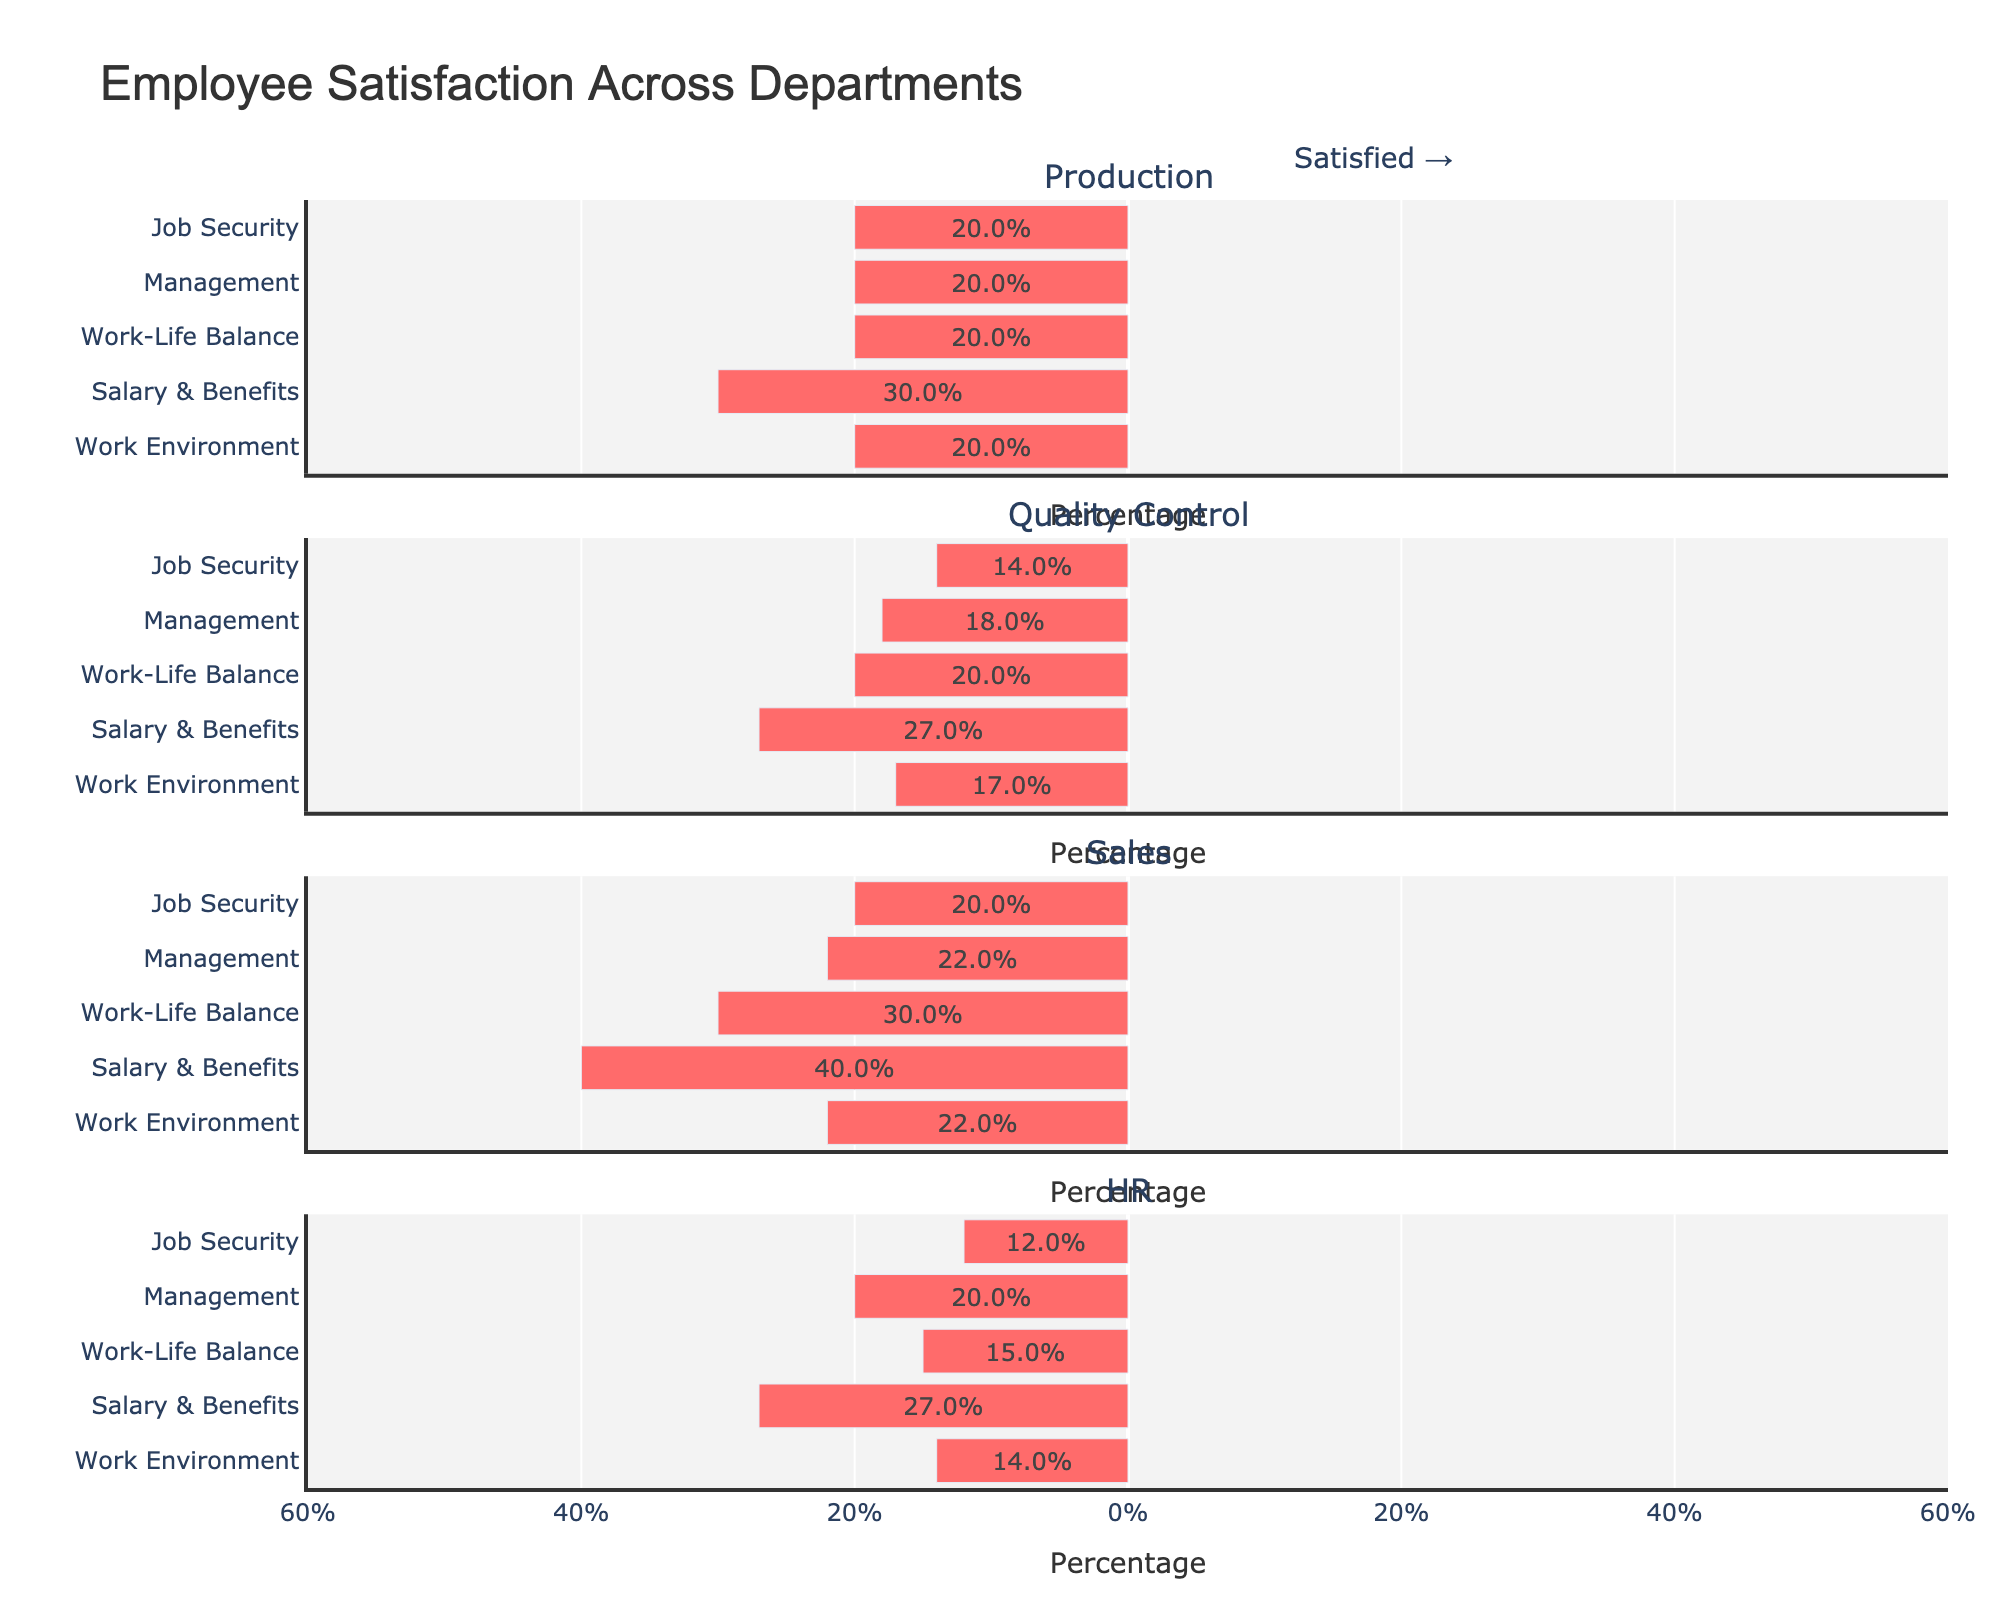What is the overall satisfaction percentage for the Production department’s Work Environment? The overall satisfaction percentage can be calculated by summing the percentages of "Satisfied" and "Very Satisfied" categories. According to the data, these are 40% and 10%, respectively.
Answer: 50% Which department has the highest percentage of employees who are very satisfied with their Job Security? Compare the "Very Satisfied" category percentages for Job Security across all departments. Production has 15%, Quality Control has 19%, Sales has 20%, and HR has 15%.
Answer: Sales Among all departments, which has the lowest percentage of employees dissatisfied with Salary & Benefits? Check the "Dissatisfied" category percentages for Salary & Benefits across all departments. Production has 20%, Quality Control has 18%, Sales has 25%, and HR has 19%.
Answer: Quality Control What is the percentage difference between very dissatisfied and very satisfied Production employees regarding Work Environment? For Production, "Very Dissatisfied" for Work Environment is 5%, and "Very Satisfied" is 10%. The percentage difference is calculated by subtracting 5% from 10%.
Answer: 5% Considering the Sales department, how does the percentage of employees who are neutral about Work-Life Balance compare to those who are satisfied? For Sales, the percentage of employees who are neutral in Work-Life Balance is 25%, while those who are satisfied are 35%. 35% is higher than 25%.
Answer: Satisfied percentage is higher In the HR department, which category has the widest range of satisfaction levels from very dissatisfied to very satisfied? For HR, compare the ranges of satisfaction levels for each category ("Very Dissatisfied" to "Very Satisfied"). The categories and ranges are: Work Environment (4% to 10%), Salary & Benefits (8% to 11%), Work-Life Balance (3% to 11%), Management (6% to 14%), Job Security (2% to 15%). The widest range spans from 2% to 15%.
Answer: Job Security What is the sum of the percentages of neutral responses across all categories in Quality Control? Add the neutral response percentages for all categories in Quality Control: Work Environment (33%), Salary & Benefits (26%), Work-Life Balance (30%), Management (25%), and Job Security (29%). The sum is 33% + 26% + 30% + 25% + 29%.
Answer: 143% Does the HR department have a higher overall satisfaction percentage for Management compared to Production? HR's overall satisfaction (Satisfied + Very Satisfied) for Management is 38% + 14% = 52%. Production's overall satisfaction for Management is 40% + 12% = 52%. Both departments have the same percentage.
Answer: No, they are equal 